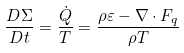<formula> <loc_0><loc_0><loc_500><loc_500>\frac { D \Sigma } { D t } = \frac { \dot { Q } } { T } = \frac { \rho \varepsilon - \nabla \cdot { F } _ { q } } { \rho T }</formula> 